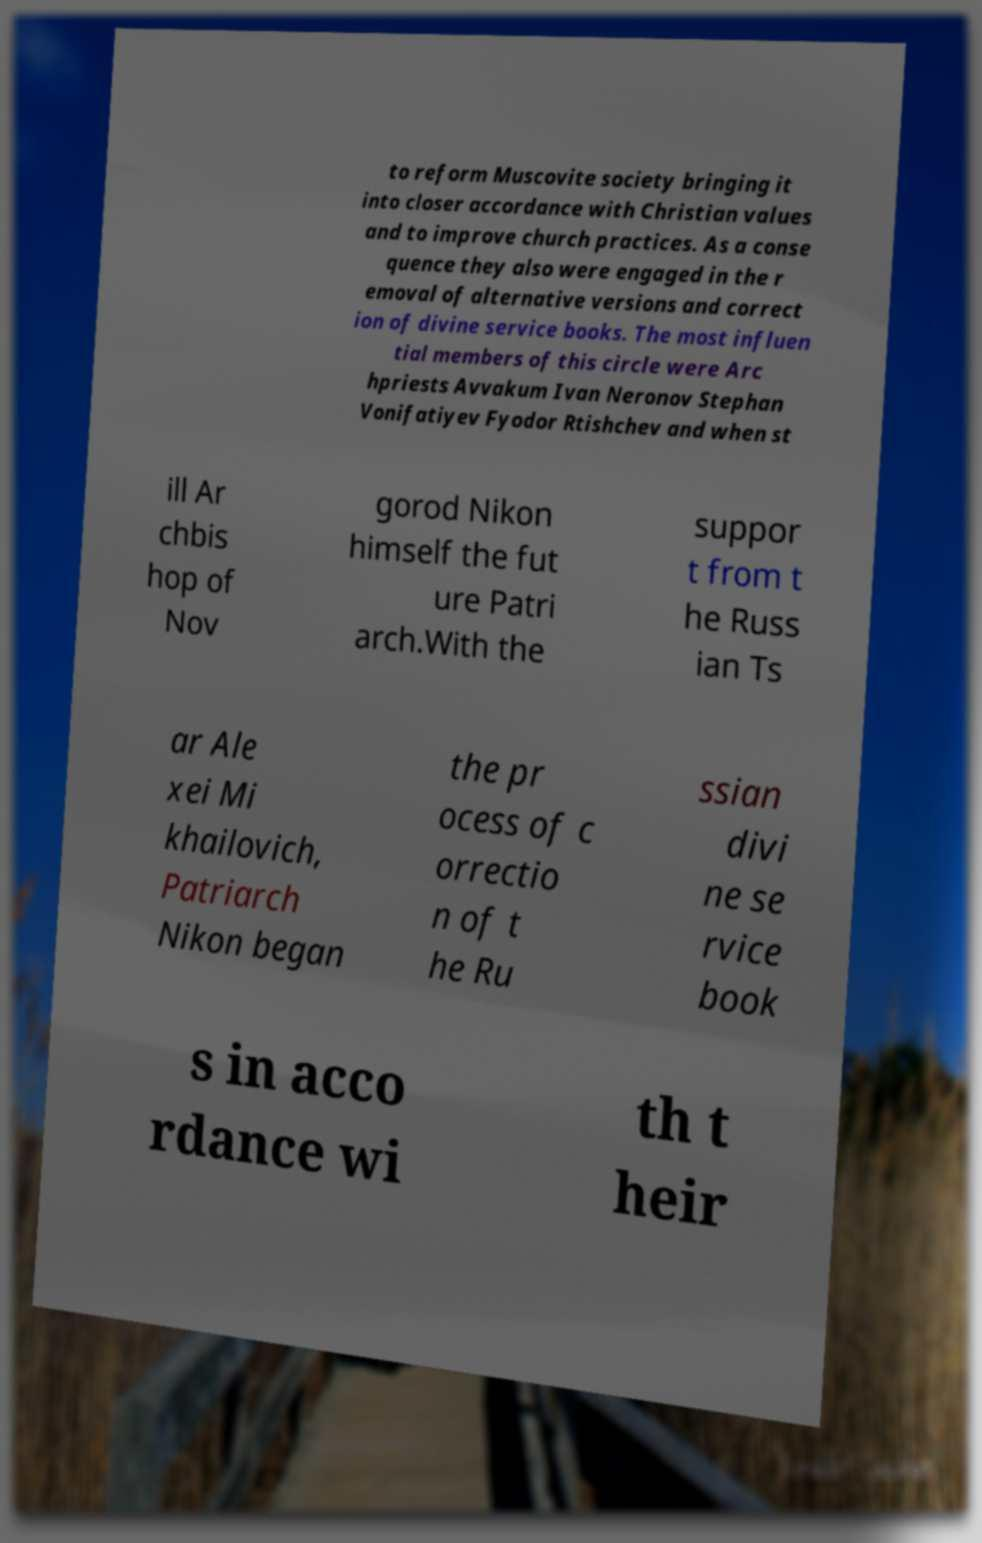For documentation purposes, I need the text within this image transcribed. Could you provide that? to reform Muscovite society bringing it into closer accordance with Christian values and to improve church practices. As a conse quence they also were engaged in the r emoval of alternative versions and correct ion of divine service books. The most influen tial members of this circle were Arc hpriests Avvakum Ivan Neronov Stephan Vonifatiyev Fyodor Rtishchev and when st ill Ar chbis hop of Nov gorod Nikon himself the fut ure Patri arch.With the suppor t from t he Russ ian Ts ar Ale xei Mi khailovich, Patriarch Nikon began the pr ocess of c orrectio n of t he Ru ssian divi ne se rvice book s in acco rdance wi th t heir 